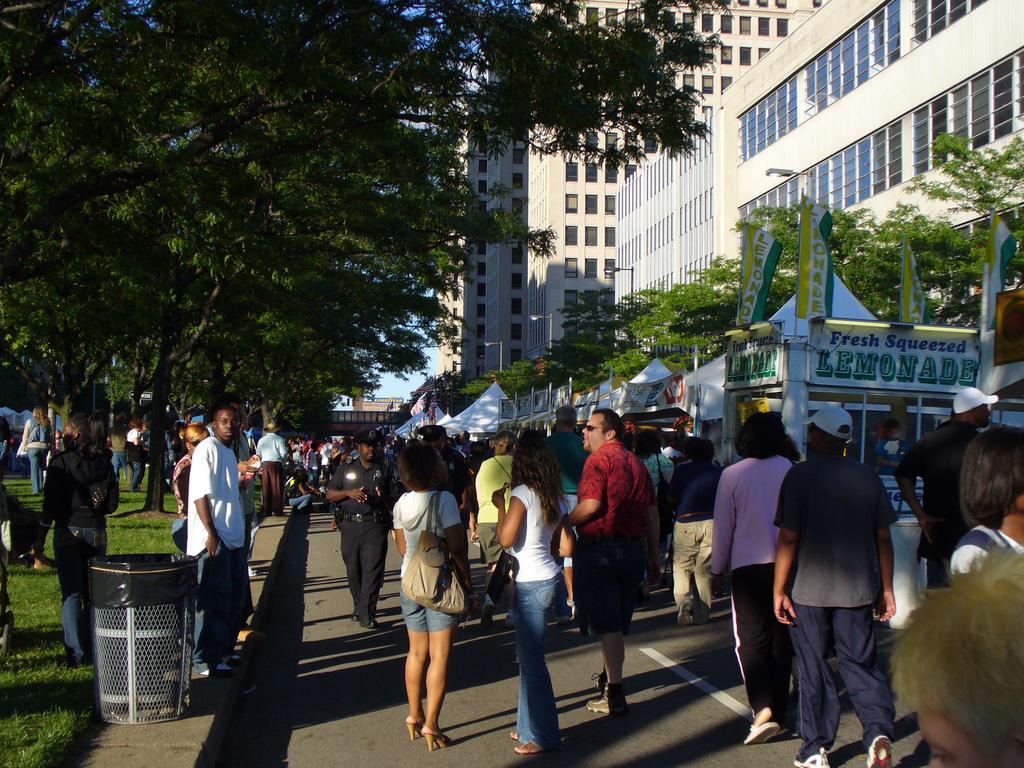Could you give a brief overview of what you see in this image? In this picture we can see group of people, few are standing and few are walking, on the left side of the image we can see a dustbin, in the background we can find few trees, buildings, poles and tents. 